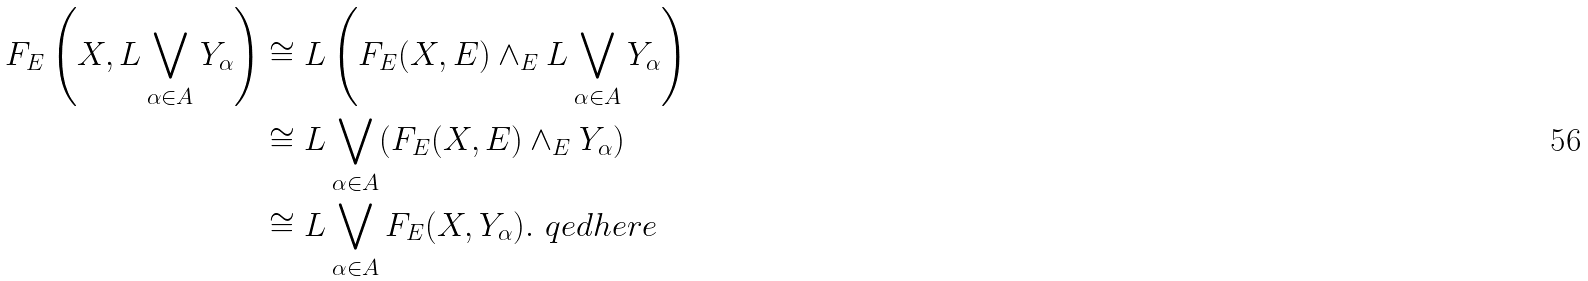Convert formula to latex. <formula><loc_0><loc_0><loc_500><loc_500>F _ { E } \left ( X , L \bigvee _ { \alpha \in A } Y _ { \alpha } \right ) & \cong L \left ( F _ { E } ( X , E ) \wedge _ { E } L \bigvee _ { \alpha \in A } Y _ { \alpha } \right ) \\ & \cong L \bigvee _ { \alpha \in A } ( F _ { E } ( X , E ) \wedge _ { E } Y _ { \alpha } ) \\ & \cong L \bigvee _ { \alpha \in A } F _ { E } ( X , Y _ { \alpha } ) . \ q e d h e r e</formula> 